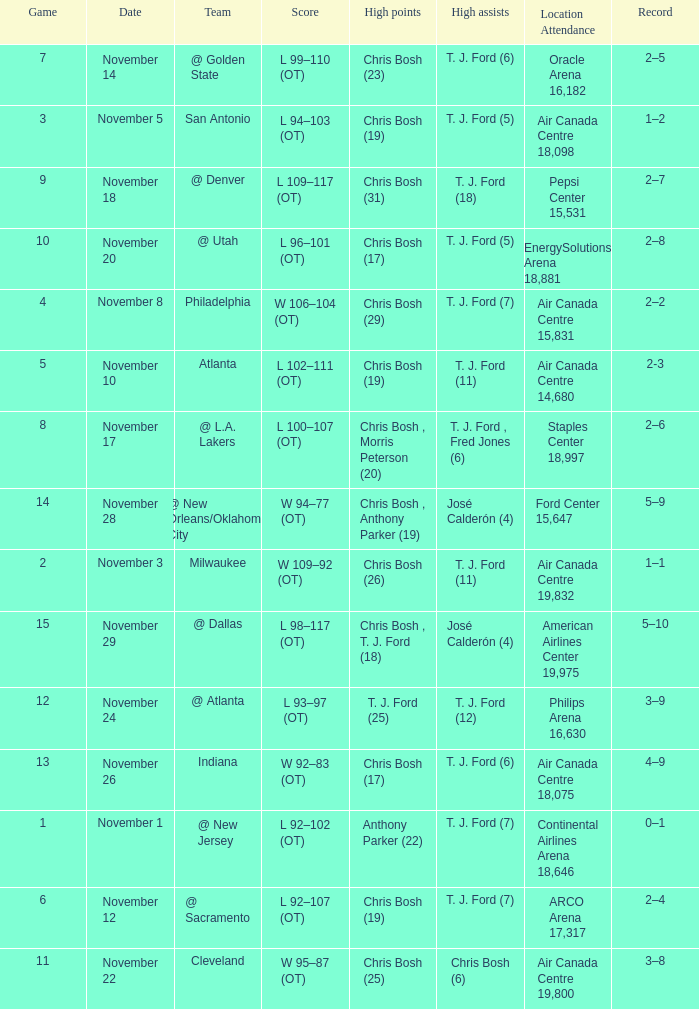What team played on November 28? @ New Orleans/Oklahoma City. 